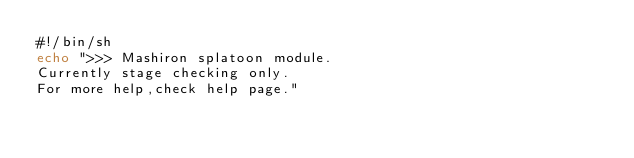Convert code to text. <code><loc_0><loc_0><loc_500><loc_500><_Bash_>#!/bin/sh
echo ">>> Mashiron splatoon module.
Currently stage checking only.
For more help,check help page."
</code> 